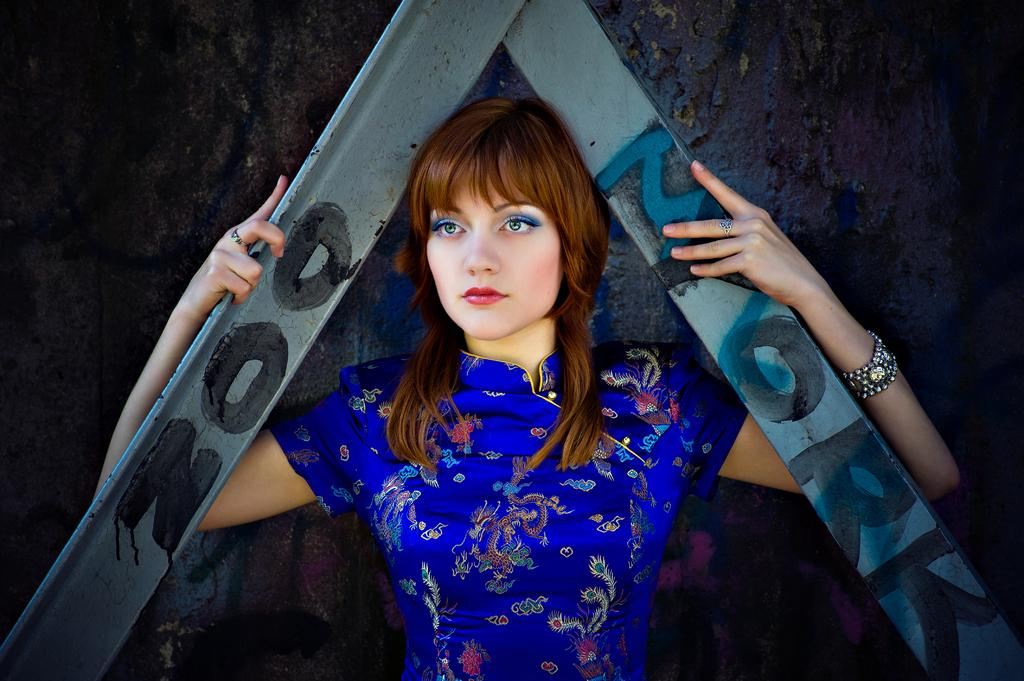What is the main subject of the image? There is a woman standing in the image. What is the woman holding in her hands? The woman is holding metal rods in her hands. Can you describe any text visible in the image? There is text on the roads in the image. What can be seen in the background of the image? There is a wall in the background of the image. What type of ear is visible on the wall in the image? There is no ear visible on the wall in the image. What kind of boundary is depicted by the text on the roads in the image? The text on the roads does not depict a boundary; it is simply text on the roads. 